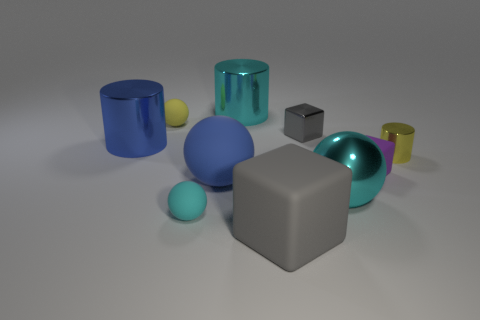There is a small yellow matte sphere to the left of the tiny gray block; is there a blue ball behind it?
Offer a very short reply. No. The other block that is the same color as the big cube is what size?
Your response must be concise. Small. The large cyan metallic object that is on the left side of the big rubber cube has what shape?
Keep it short and to the point. Cylinder. There is a small sphere in front of the small yellow object on the left side of the tiny purple object; how many tiny purple matte objects are to the left of it?
Your response must be concise. 0. Do the cyan rubber sphere and the gray thing that is on the right side of the large gray object have the same size?
Make the answer very short. Yes. What size is the matte block that is to the left of the gray block behind the small purple object?
Offer a very short reply. Large. How many yellow objects have the same material as the tiny yellow ball?
Offer a terse response. 0. Are any big gray shiny spheres visible?
Your answer should be very brief. No. What size is the cyan metallic thing right of the big cyan cylinder?
Your answer should be very brief. Large. What number of small cylinders have the same color as the large rubber sphere?
Ensure brevity in your answer.  0. 